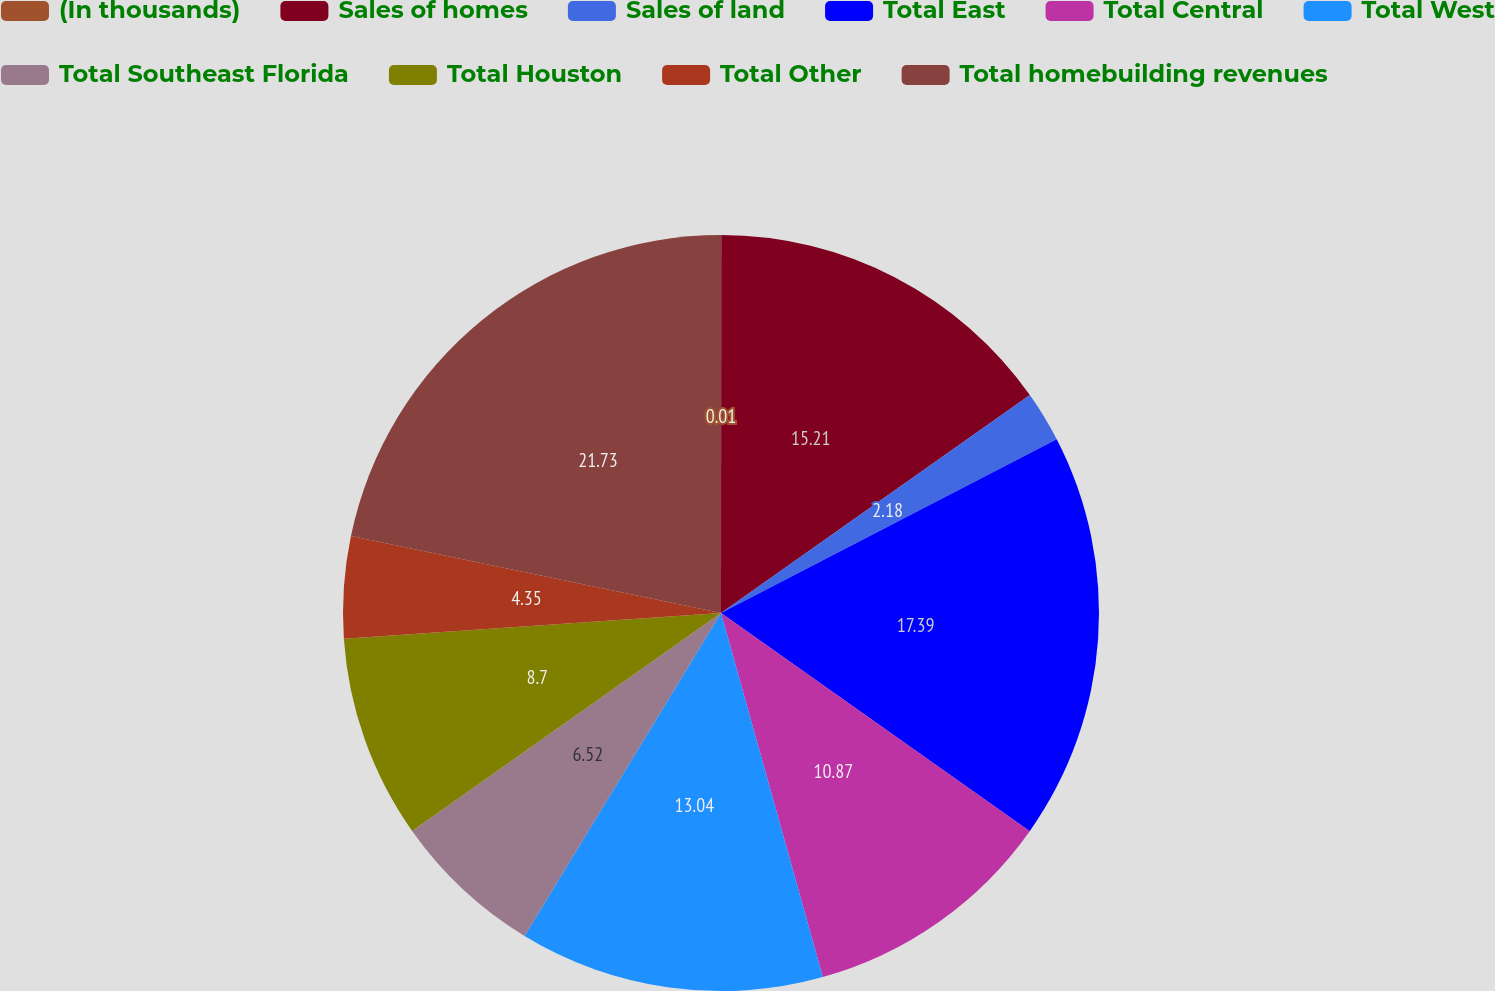Convert chart to OTSL. <chart><loc_0><loc_0><loc_500><loc_500><pie_chart><fcel>(In thousands)<fcel>Sales of homes<fcel>Sales of land<fcel>Total East<fcel>Total Central<fcel>Total West<fcel>Total Southeast Florida<fcel>Total Houston<fcel>Total Other<fcel>Total homebuilding revenues<nl><fcel>0.01%<fcel>15.21%<fcel>2.18%<fcel>17.39%<fcel>10.87%<fcel>13.04%<fcel>6.52%<fcel>8.7%<fcel>4.35%<fcel>21.73%<nl></chart> 